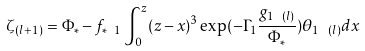<formula> <loc_0><loc_0><loc_500><loc_500>\zeta _ { ( l + 1 ) } = \Phi _ { * } - f _ { * \ 1 } \int _ { 0 } ^ { z } ( z - x ) ^ { 3 } \exp ( - \Gamma _ { 1 } \frac { g _ { 1 \ ( l ) } } { \Phi _ { * } } ) \theta _ { 1 \ ( l ) } d x</formula> 